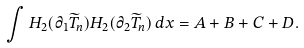Convert formula to latex. <formula><loc_0><loc_0><loc_500><loc_500>\int H _ { 2 } ( \partial _ { 1 } \widetilde { T } _ { n } ) H _ { 2 } ( \partial _ { 2 } \widetilde { T } _ { n } ) \, d x = A + B + C + D .</formula> 